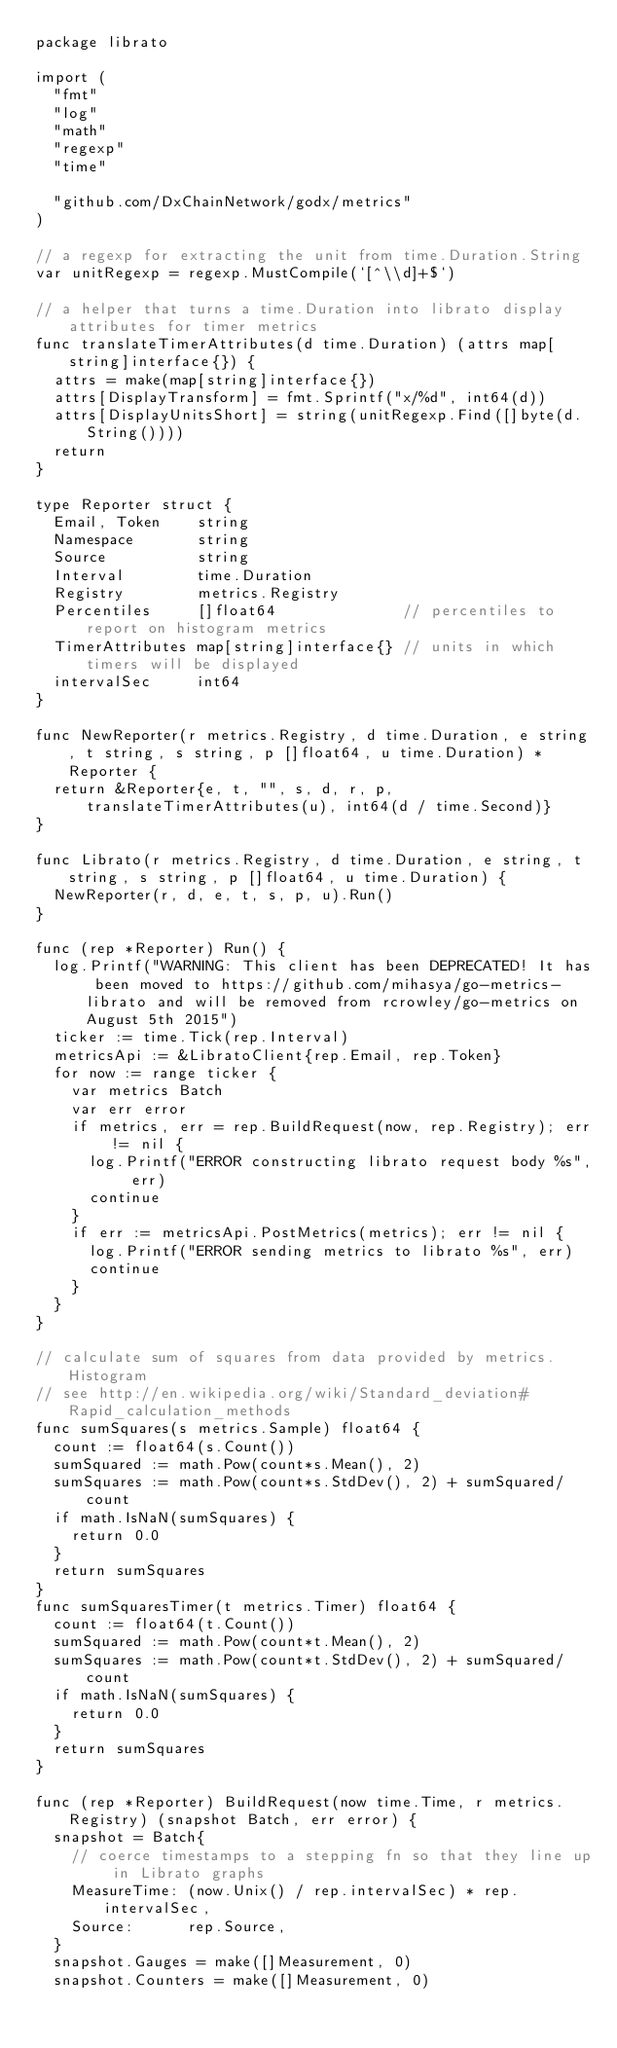Convert code to text. <code><loc_0><loc_0><loc_500><loc_500><_Go_>package librato

import (
	"fmt"
	"log"
	"math"
	"regexp"
	"time"

	"github.com/DxChainNetwork/godx/metrics"
)

// a regexp for extracting the unit from time.Duration.String
var unitRegexp = regexp.MustCompile(`[^\\d]+$`)

// a helper that turns a time.Duration into librato display attributes for timer metrics
func translateTimerAttributes(d time.Duration) (attrs map[string]interface{}) {
	attrs = make(map[string]interface{})
	attrs[DisplayTransform] = fmt.Sprintf("x/%d", int64(d))
	attrs[DisplayUnitsShort] = string(unitRegexp.Find([]byte(d.String())))
	return
}

type Reporter struct {
	Email, Token    string
	Namespace       string
	Source          string
	Interval        time.Duration
	Registry        metrics.Registry
	Percentiles     []float64              // percentiles to report on histogram metrics
	TimerAttributes map[string]interface{} // units in which timers will be displayed
	intervalSec     int64
}

func NewReporter(r metrics.Registry, d time.Duration, e string, t string, s string, p []float64, u time.Duration) *Reporter {
	return &Reporter{e, t, "", s, d, r, p, translateTimerAttributes(u), int64(d / time.Second)}
}

func Librato(r metrics.Registry, d time.Duration, e string, t string, s string, p []float64, u time.Duration) {
	NewReporter(r, d, e, t, s, p, u).Run()
}

func (rep *Reporter) Run() {
	log.Printf("WARNING: This client has been DEPRECATED! It has been moved to https://github.com/mihasya/go-metrics-librato and will be removed from rcrowley/go-metrics on August 5th 2015")
	ticker := time.Tick(rep.Interval)
	metricsApi := &LibratoClient{rep.Email, rep.Token}
	for now := range ticker {
		var metrics Batch
		var err error
		if metrics, err = rep.BuildRequest(now, rep.Registry); err != nil {
			log.Printf("ERROR constructing librato request body %s", err)
			continue
		}
		if err := metricsApi.PostMetrics(metrics); err != nil {
			log.Printf("ERROR sending metrics to librato %s", err)
			continue
		}
	}
}

// calculate sum of squares from data provided by metrics.Histogram
// see http://en.wikipedia.org/wiki/Standard_deviation#Rapid_calculation_methods
func sumSquares(s metrics.Sample) float64 {
	count := float64(s.Count())
	sumSquared := math.Pow(count*s.Mean(), 2)
	sumSquares := math.Pow(count*s.StdDev(), 2) + sumSquared/count
	if math.IsNaN(sumSquares) {
		return 0.0
	}
	return sumSquares
}
func sumSquaresTimer(t metrics.Timer) float64 {
	count := float64(t.Count())
	sumSquared := math.Pow(count*t.Mean(), 2)
	sumSquares := math.Pow(count*t.StdDev(), 2) + sumSquared/count
	if math.IsNaN(sumSquares) {
		return 0.0
	}
	return sumSquares
}

func (rep *Reporter) BuildRequest(now time.Time, r metrics.Registry) (snapshot Batch, err error) {
	snapshot = Batch{
		// coerce timestamps to a stepping fn so that they line up in Librato graphs
		MeasureTime: (now.Unix() / rep.intervalSec) * rep.intervalSec,
		Source:      rep.Source,
	}
	snapshot.Gauges = make([]Measurement, 0)
	snapshot.Counters = make([]Measurement, 0)</code> 